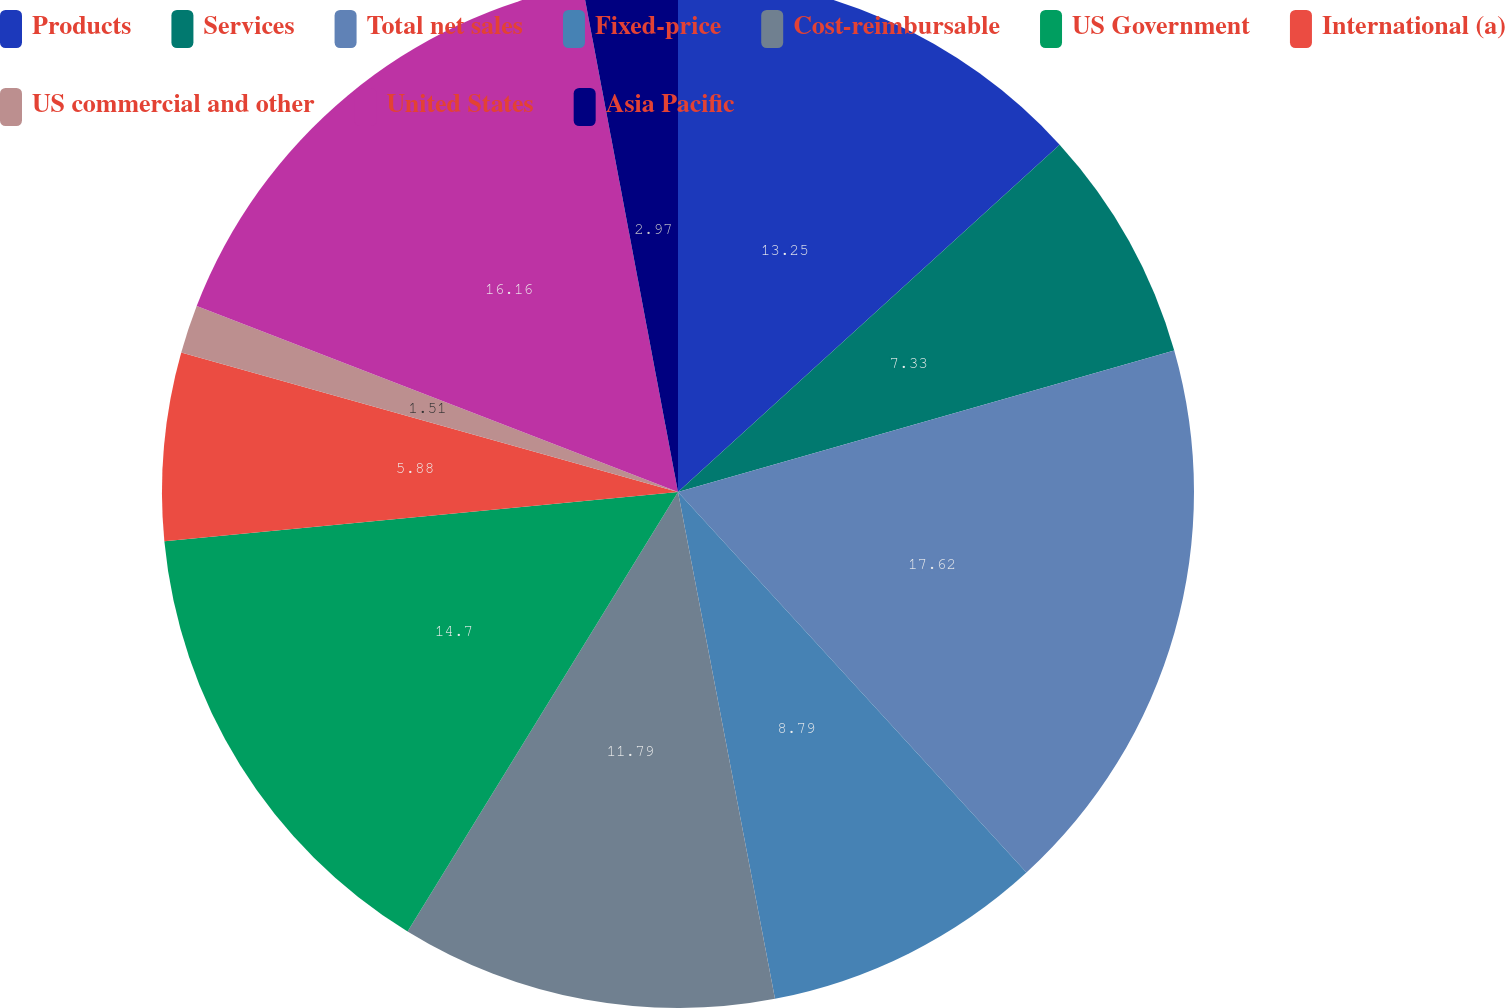Convert chart. <chart><loc_0><loc_0><loc_500><loc_500><pie_chart><fcel>Products<fcel>Services<fcel>Total net sales<fcel>Fixed-price<fcel>Cost-reimbursable<fcel>US Government<fcel>International (a)<fcel>US commercial and other<fcel>United States<fcel>Asia Pacific<nl><fcel>13.25%<fcel>7.33%<fcel>17.62%<fcel>8.79%<fcel>11.79%<fcel>14.7%<fcel>5.88%<fcel>1.51%<fcel>16.16%<fcel>2.97%<nl></chart> 